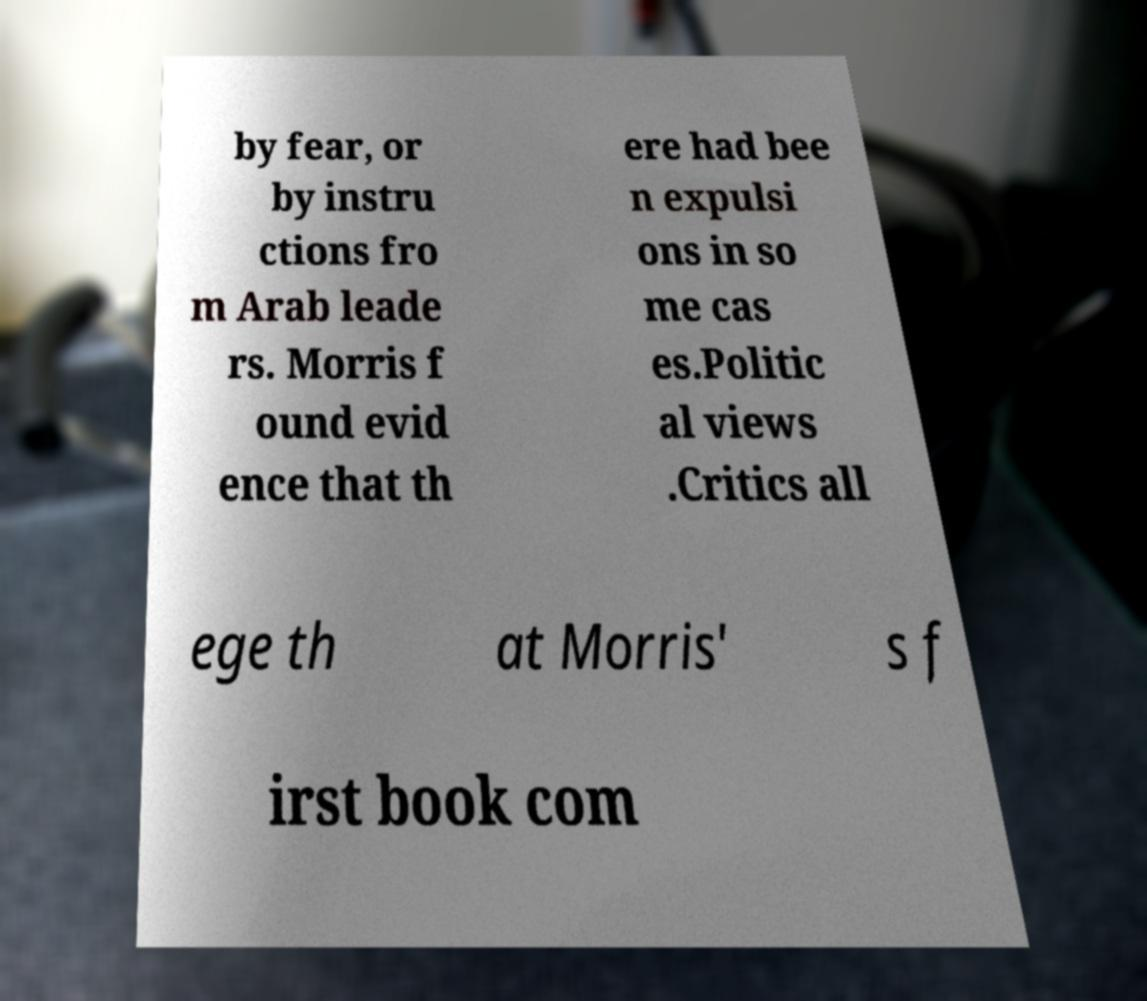Can you read and provide the text displayed in the image?This photo seems to have some interesting text. Can you extract and type it out for me? by fear, or by instru ctions fro m Arab leade rs. Morris f ound evid ence that th ere had bee n expulsi ons in so me cas es.Politic al views .Critics all ege th at Morris' s f irst book com 